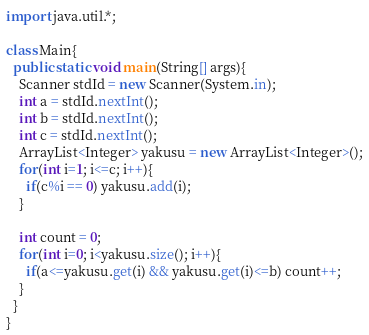<code> <loc_0><loc_0><loc_500><loc_500><_Java_>import java.util.*;
  
class Main{
  public static void main(String[] args){
    Scanner stdId = new Scanner(System.in);
    int a = stdId.nextInt(); 
    int b = stdId.nextInt(); 
    int c = stdId.nextInt(); 
    ArrayList<Integer> yakusu = new ArrayList<Integer>();
    for(int i=1; i<=c; i++){
      if(c%i == 0) yakusu.add(i);
    }

    int count = 0;
    for(int i=0; i<yakusu.size(); i++){
      if(a<=yakusu.get(i) && yakusu.get(i)<=b) count++;
    }
  }
}</code> 